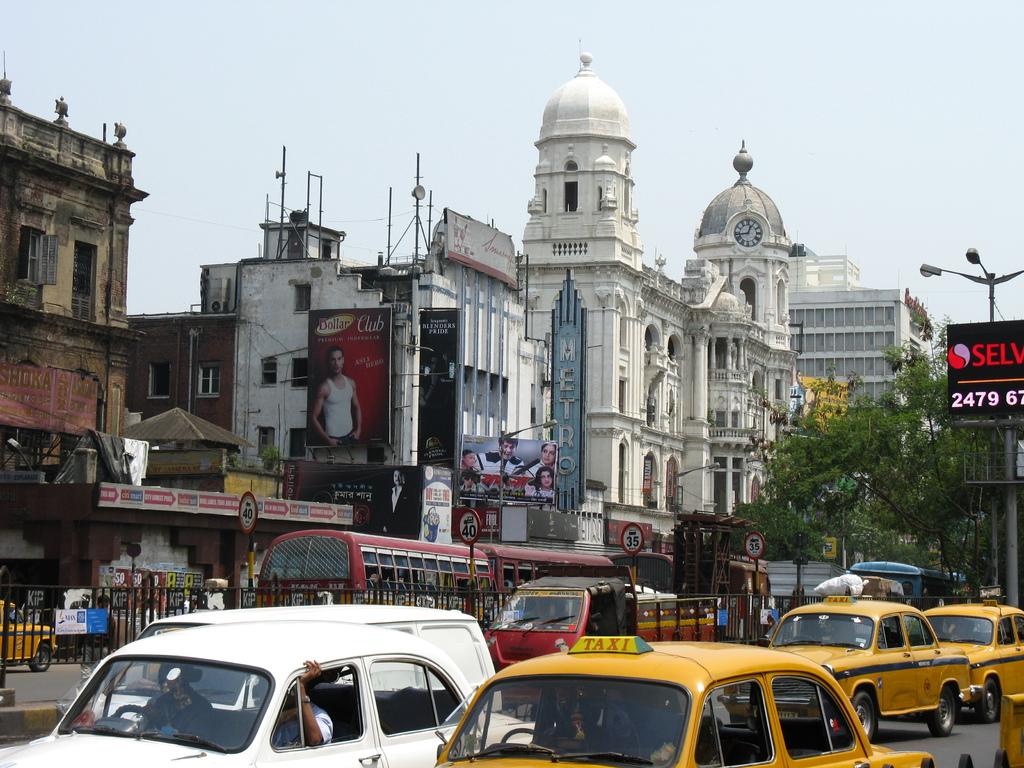What is the yellow car?
Ensure brevity in your answer.  Taxi. 